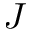<formula> <loc_0><loc_0><loc_500><loc_500>J</formula> 